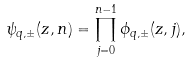Convert formula to latex. <formula><loc_0><loc_0><loc_500><loc_500>\psi _ { q , \pm } ( z , n ) = \prod _ { j = 0 } ^ { n - 1 } \phi _ { q , \pm } ( z , j ) ,</formula> 